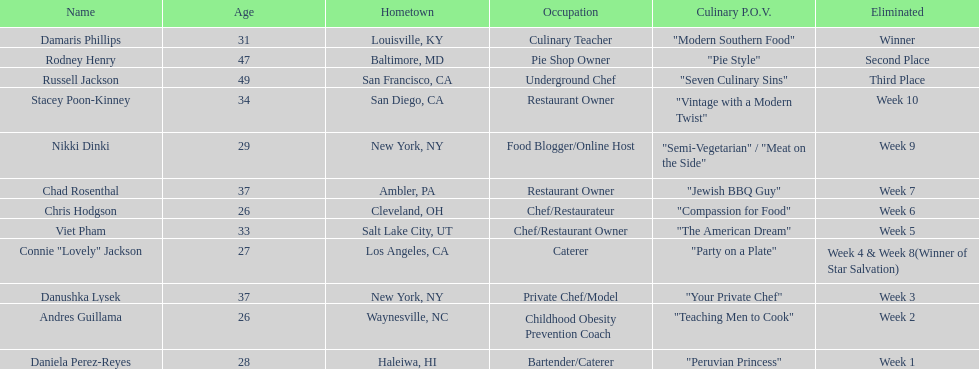Which participant was the first to leave the competition in food network star season 9? Daniela Perez-Reyes. 